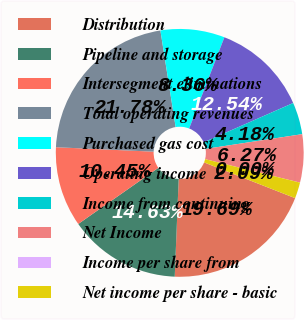Convert chart. <chart><loc_0><loc_0><loc_500><loc_500><pie_chart><fcel>Distribution<fcel>Pipeline and storage<fcel>Intersegment eliminations<fcel>Total operating revenues<fcel>Purchased gas cost<fcel>Operating income<fcel>Income from continuing<fcel>Net Income<fcel>Income per share from<fcel>Net income per share - basic<nl><fcel>19.69%<fcel>14.63%<fcel>10.45%<fcel>21.78%<fcel>8.36%<fcel>12.54%<fcel>4.18%<fcel>6.27%<fcel>0.0%<fcel>2.09%<nl></chart> 